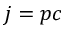<formula> <loc_0><loc_0><loc_500><loc_500>j = p c</formula> 